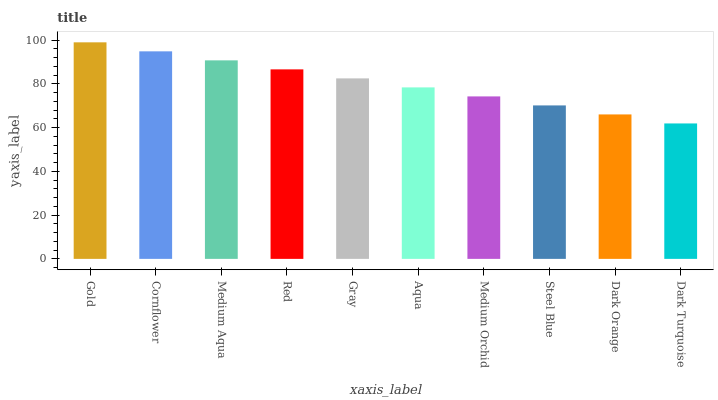Is Dark Turquoise the minimum?
Answer yes or no. Yes. Is Gold the maximum?
Answer yes or no. Yes. Is Cornflower the minimum?
Answer yes or no. No. Is Cornflower the maximum?
Answer yes or no. No. Is Gold greater than Cornflower?
Answer yes or no. Yes. Is Cornflower less than Gold?
Answer yes or no. Yes. Is Cornflower greater than Gold?
Answer yes or no. No. Is Gold less than Cornflower?
Answer yes or no. No. Is Gray the high median?
Answer yes or no. Yes. Is Aqua the low median?
Answer yes or no. Yes. Is Cornflower the high median?
Answer yes or no. No. Is Gray the low median?
Answer yes or no. No. 